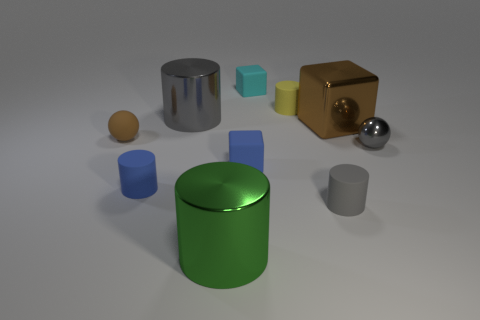Are there the same number of large blocks in front of the small gray metallic sphere and small cyan cubes? no 